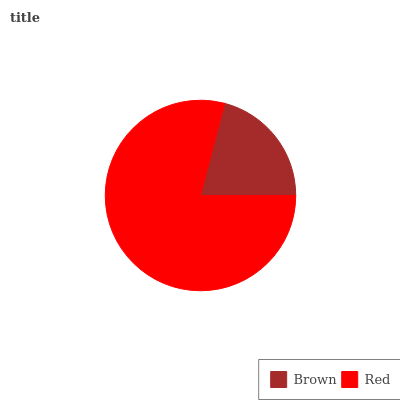Is Brown the minimum?
Answer yes or no. Yes. Is Red the maximum?
Answer yes or no. Yes. Is Red the minimum?
Answer yes or no. No. Is Red greater than Brown?
Answer yes or no. Yes. Is Brown less than Red?
Answer yes or no. Yes. Is Brown greater than Red?
Answer yes or no. No. Is Red less than Brown?
Answer yes or no. No. Is Red the high median?
Answer yes or no. Yes. Is Brown the low median?
Answer yes or no. Yes. Is Brown the high median?
Answer yes or no. No. Is Red the low median?
Answer yes or no. No. 